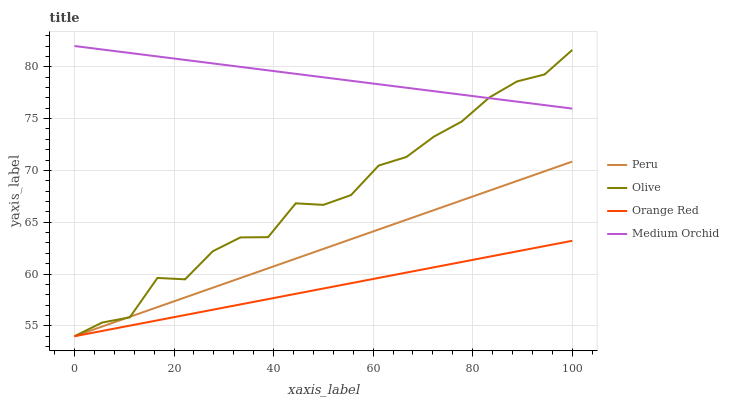Does Medium Orchid have the minimum area under the curve?
Answer yes or no. No. Does Orange Red have the maximum area under the curve?
Answer yes or no. No. Is Medium Orchid the smoothest?
Answer yes or no. No. Is Medium Orchid the roughest?
Answer yes or no. No. Does Medium Orchid have the lowest value?
Answer yes or no. No. Does Orange Red have the highest value?
Answer yes or no. No. Is Peru less than Medium Orchid?
Answer yes or no. Yes. Is Medium Orchid greater than Orange Red?
Answer yes or no. Yes. Does Peru intersect Medium Orchid?
Answer yes or no. No. 